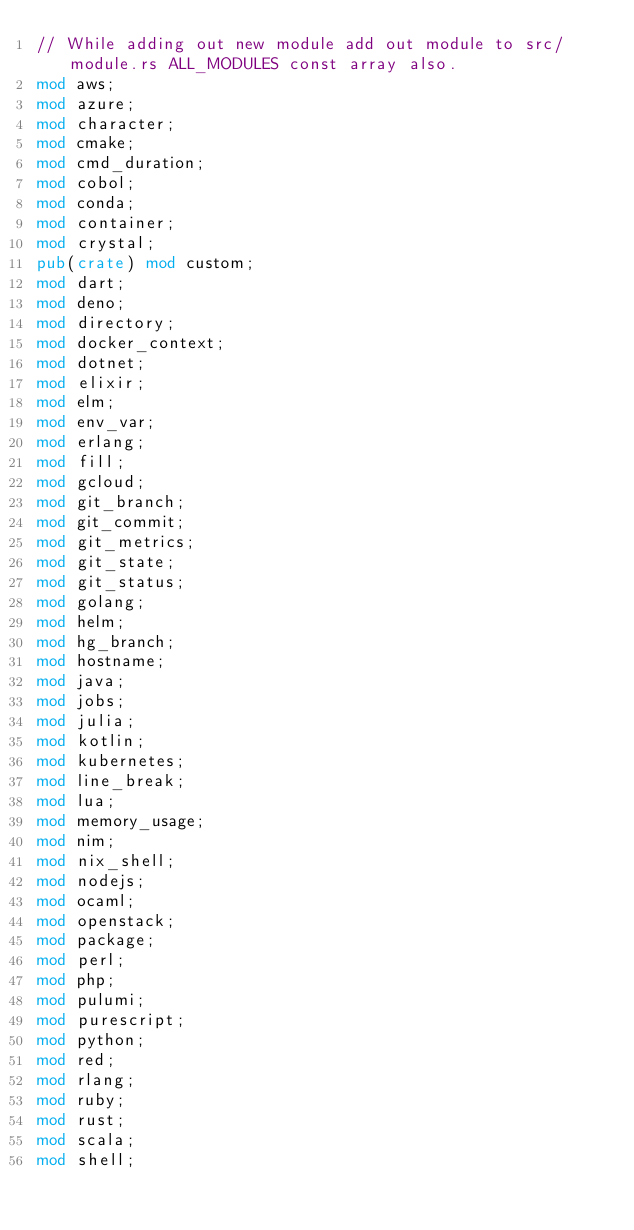Convert code to text. <code><loc_0><loc_0><loc_500><loc_500><_Rust_>// While adding out new module add out module to src/module.rs ALL_MODULES const array also.
mod aws;
mod azure;
mod character;
mod cmake;
mod cmd_duration;
mod cobol;
mod conda;
mod container;
mod crystal;
pub(crate) mod custom;
mod dart;
mod deno;
mod directory;
mod docker_context;
mod dotnet;
mod elixir;
mod elm;
mod env_var;
mod erlang;
mod fill;
mod gcloud;
mod git_branch;
mod git_commit;
mod git_metrics;
mod git_state;
mod git_status;
mod golang;
mod helm;
mod hg_branch;
mod hostname;
mod java;
mod jobs;
mod julia;
mod kotlin;
mod kubernetes;
mod line_break;
mod lua;
mod memory_usage;
mod nim;
mod nix_shell;
mod nodejs;
mod ocaml;
mod openstack;
mod package;
mod perl;
mod php;
mod pulumi;
mod purescript;
mod python;
mod red;
mod rlang;
mod ruby;
mod rust;
mod scala;
mod shell;</code> 